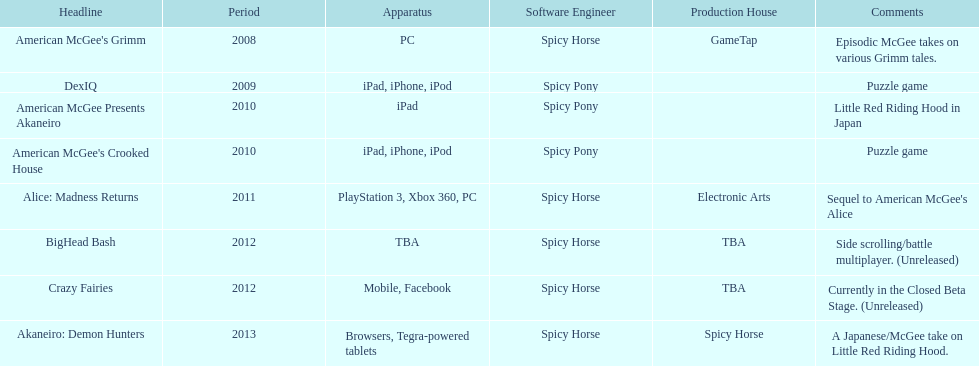Spicy pony released a total of three games; their game, "american mcgee's crooked house" was released on which platforms? Ipad, iphone, ipod. 